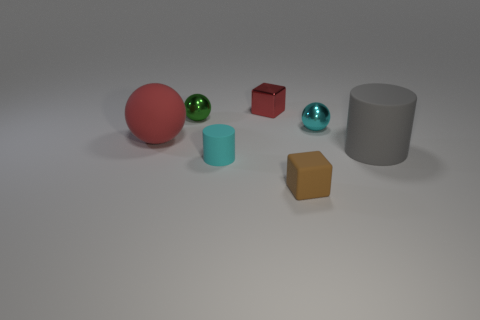What size is the gray object that is the same material as the large sphere?
Make the answer very short. Large. There is a metallic object on the left side of the small metal cube; is it the same shape as the big red matte thing?
Ensure brevity in your answer.  Yes. There is a sphere that is the same color as the tiny cylinder; what size is it?
Your answer should be compact. Small. How many red objects are either small blocks or small shiny cubes?
Your answer should be compact. 1. What number of other things are there of the same shape as the tiny brown object?
Provide a succinct answer. 1. There is a matte thing that is on the right side of the tiny red shiny object and on the left side of the gray matte cylinder; what is its shape?
Keep it short and to the point. Cube. There is a small green thing; are there any red shiny things in front of it?
Your answer should be compact. No. The cyan matte thing that is the same shape as the large gray thing is what size?
Make the answer very short. Small. Is there any other thing that is the same size as the brown cube?
Give a very brief answer. Yes. Is the brown thing the same shape as the cyan metallic object?
Your response must be concise. No. 